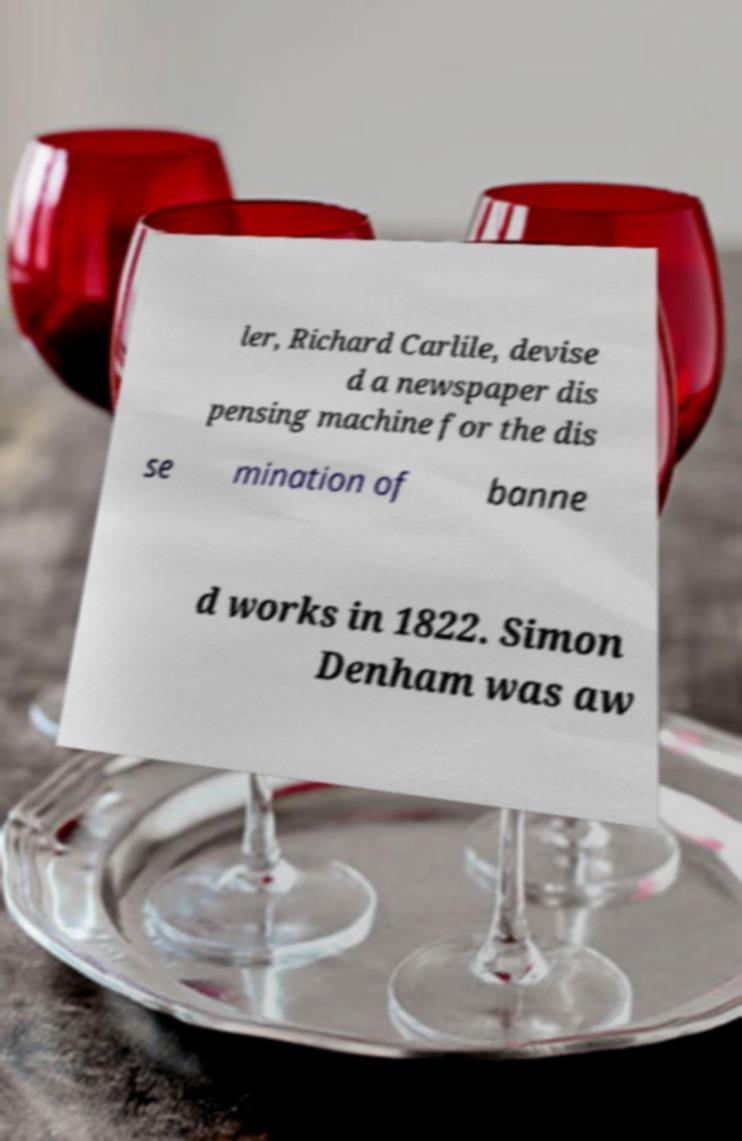I need the written content from this picture converted into text. Can you do that? ler, Richard Carlile, devise d a newspaper dis pensing machine for the dis se mination of banne d works in 1822. Simon Denham was aw 